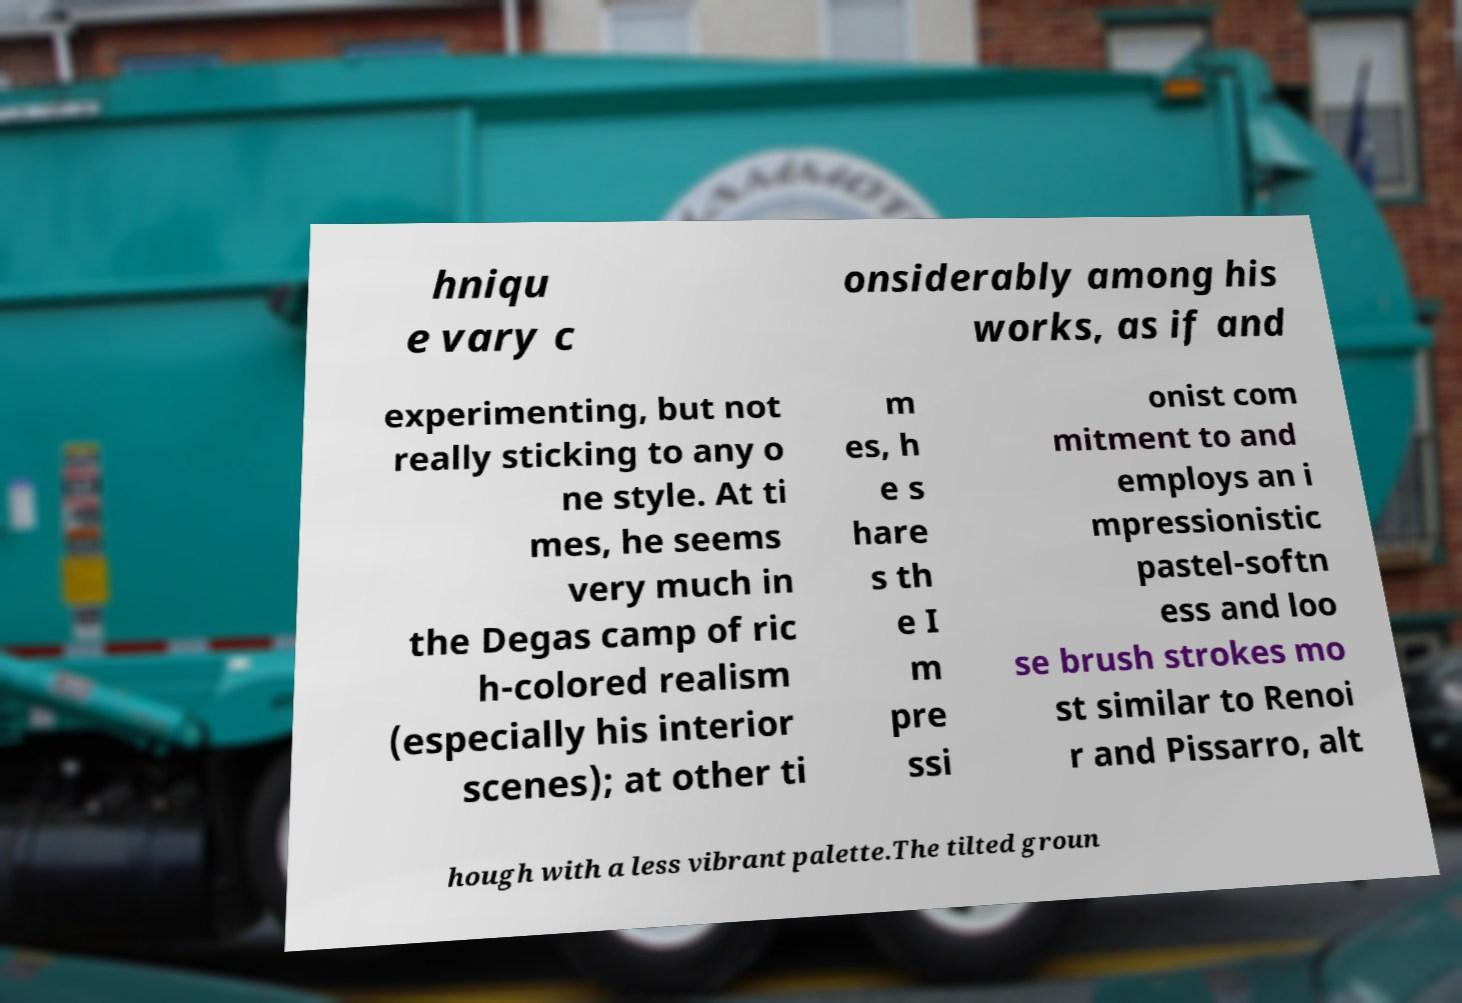Please read and relay the text visible in this image. What does it say? hniqu e vary c onsiderably among his works, as if and experimenting, but not really sticking to any o ne style. At ti mes, he seems very much in the Degas camp of ric h-colored realism (especially his interior scenes); at other ti m es, h e s hare s th e I m pre ssi onist com mitment to and employs an i mpressionistic pastel-softn ess and loo se brush strokes mo st similar to Renoi r and Pissarro, alt hough with a less vibrant palette.The tilted groun 